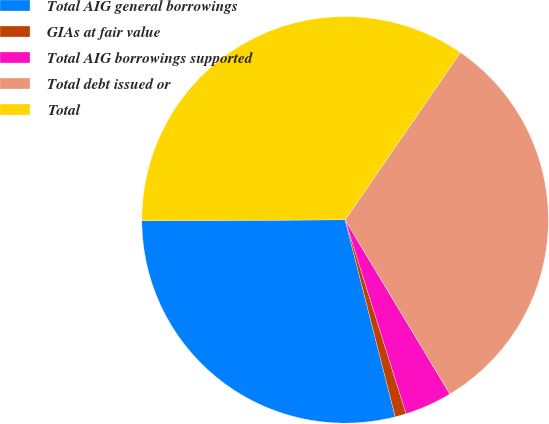Convert chart to OTSL. <chart><loc_0><loc_0><loc_500><loc_500><pie_chart><fcel>Total AIG general borrowings<fcel>GIAs at fair value<fcel>Total AIG borrowings supported<fcel>Total debt issued or<fcel>Total<nl><fcel>28.89%<fcel>0.88%<fcel>3.77%<fcel>31.78%<fcel>34.67%<nl></chart> 